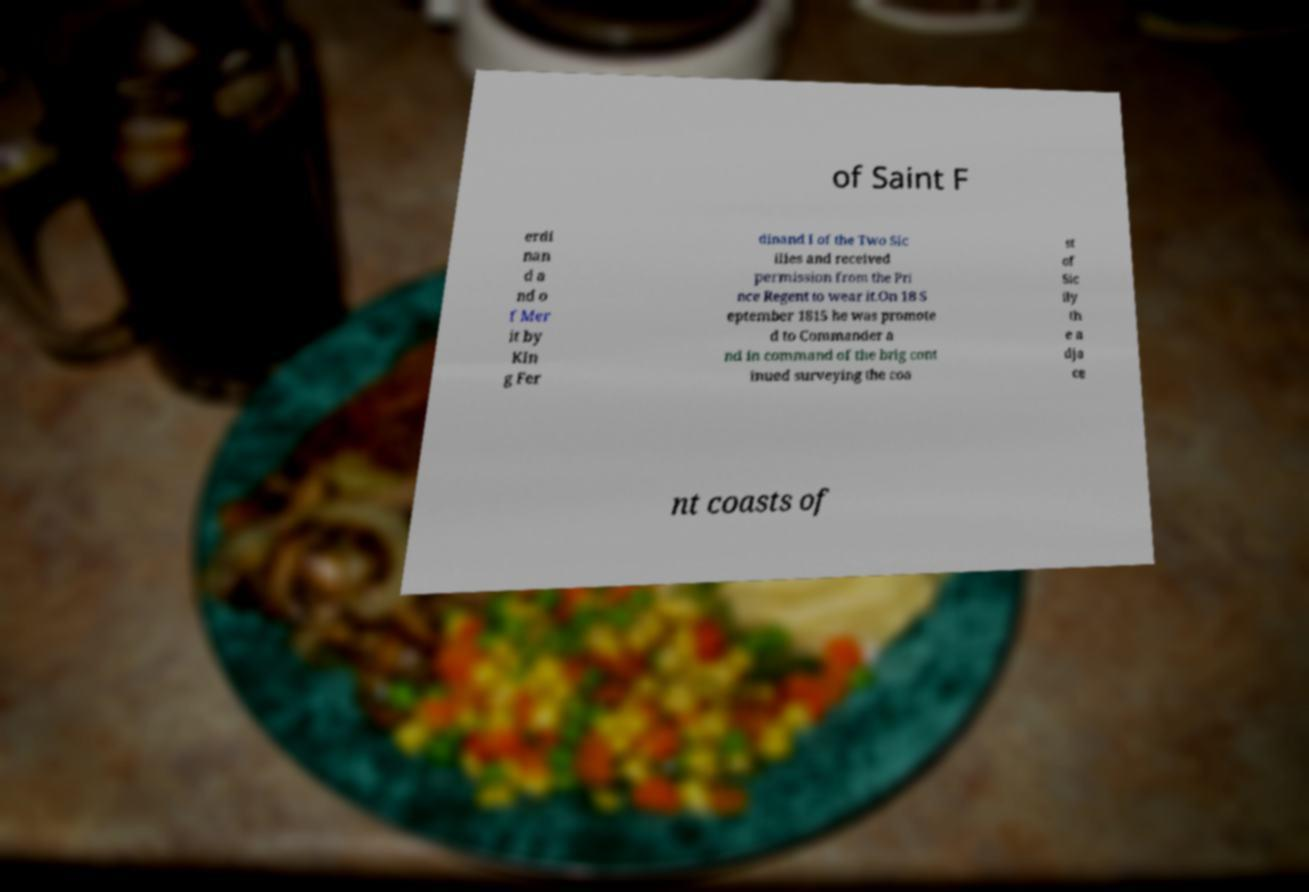For documentation purposes, I need the text within this image transcribed. Could you provide that? of Saint F erdi nan d a nd o f Mer it by Kin g Fer dinand I of the Two Sic ilies and received permission from the Pri nce Regent to wear it.On 18 S eptember 1815 he was promote d to Commander a nd in command of the brig cont inued surveying the coa st of Sic ily th e a dja ce nt coasts of 